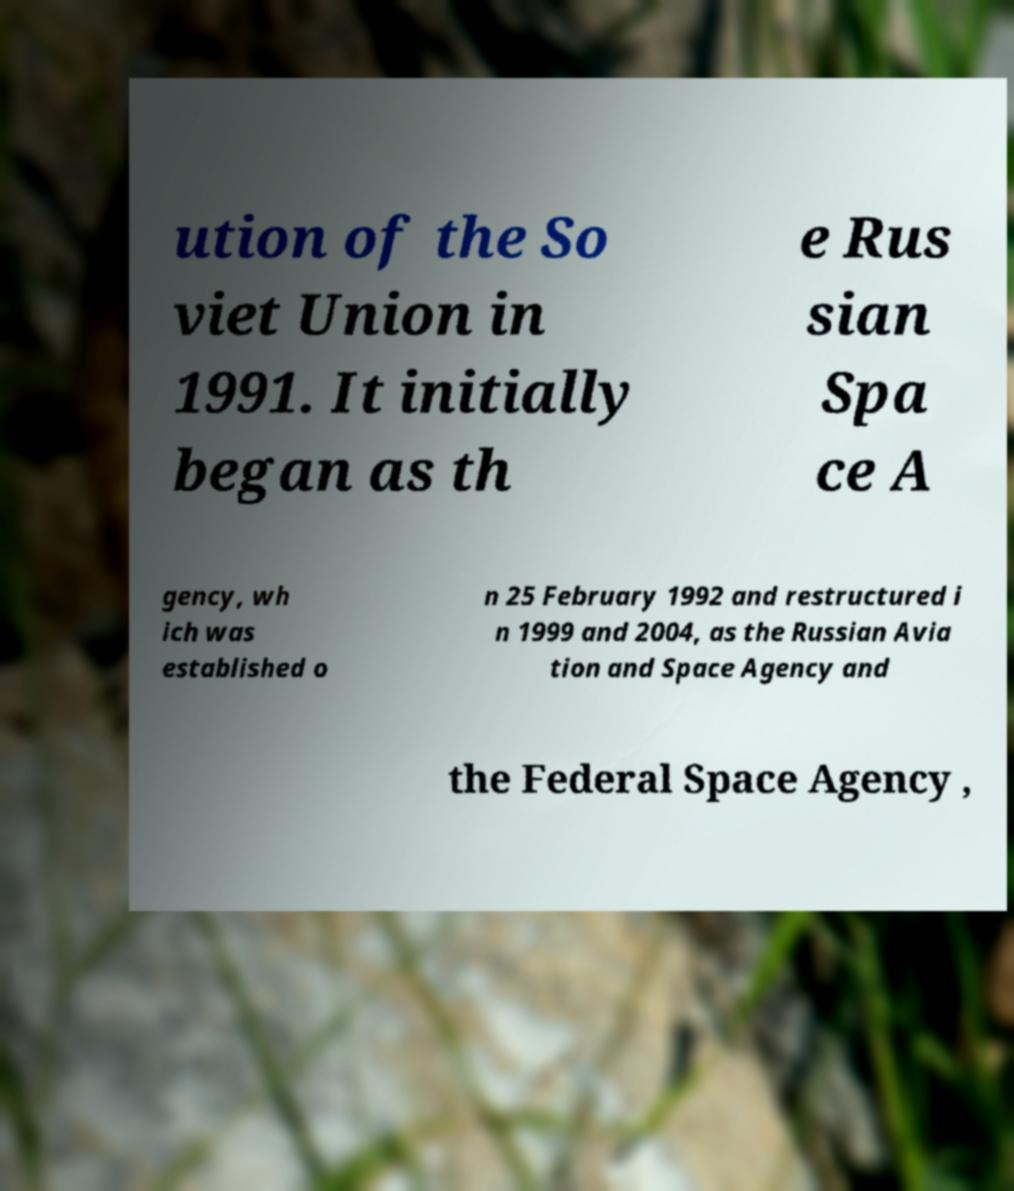Can you accurately transcribe the text from the provided image for me? ution of the So viet Union in 1991. It initially began as th e Rus sian Spa ce A gency, wh ich was established o n 25 February 1992 and restructured i n 1999 and 2004, as the Russian Avia tion and Space Agency and the Federal Space Agency , 